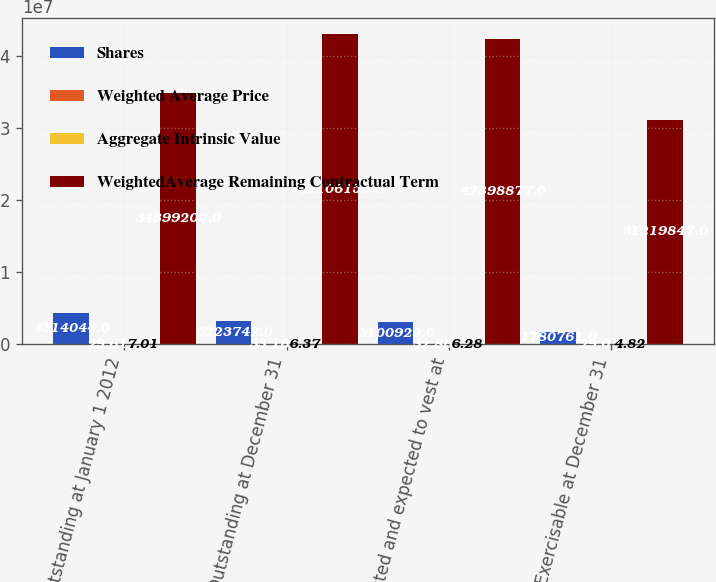<chart> <loc_0><loc_0><loc_500><loc_500><stacked_bar_chart><ecel><fcel>Outstanding at January 1 2012<fcel>Outstanding at December 31<fcel>Vested and expected to vest at<fcel>Exercisable at December 31<nl><fcel>Shares<fcel>4.31404e+06<fcel>3.22374e+06<fcel>3.10093e+06<fcel>1.78076e+06<nl><fcel>Weighted Average Price<fcel>29.61<fcel>33.16<fcel>32.86<fcel>29<nl><fcel>Aggregate Intrinsic Value<fcel>7.01<fcel>6.37<fcel>6.28<fcel>4.82<nl><fcel>WeightedAverage Remaining Contractual Term<fcel>3.48992e+07<fcel>4.31062e+07<fcel>4.23989e+07<fcel>3.12198e+07<nl></chart> 